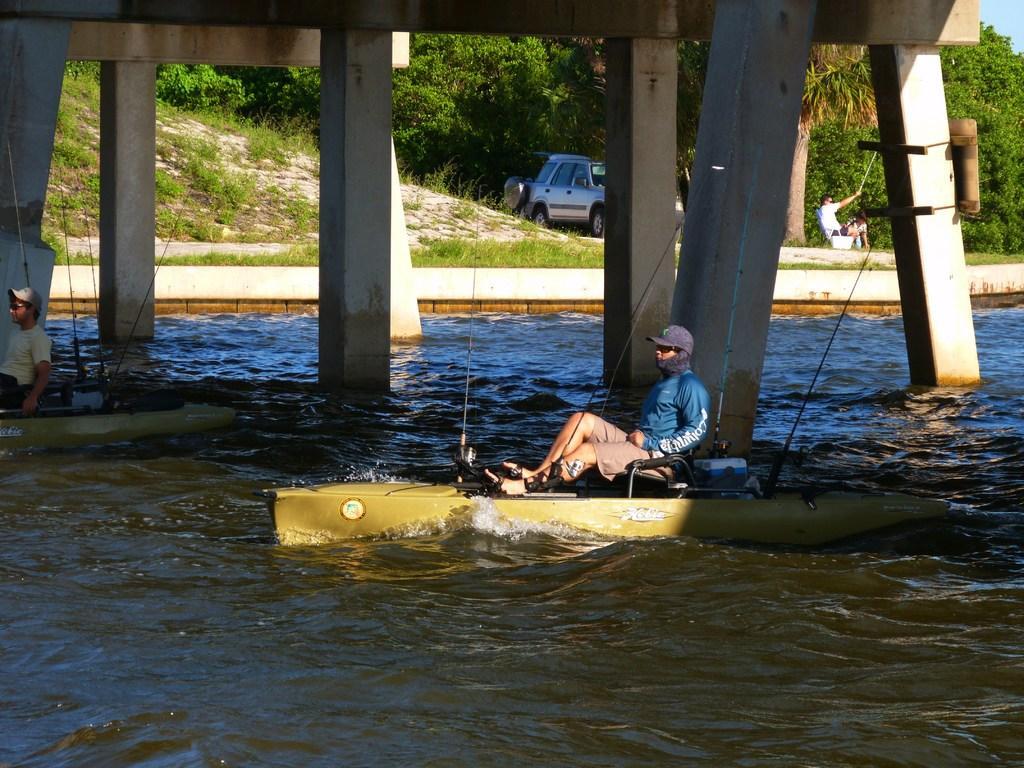How would you summarize this image in a sentence or two? In this image, we can see two persons are sailing boats on the water. Background we can see pillars, plants, vehicle, people and trees. 